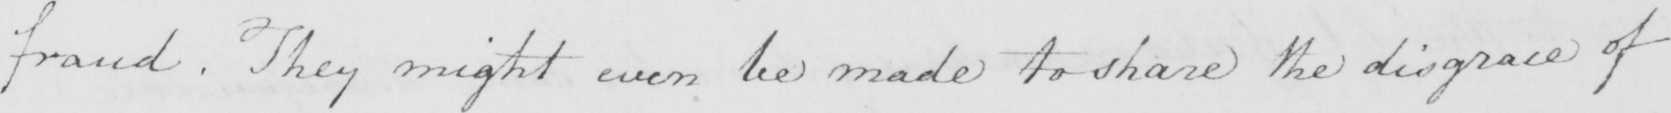What text is written in this handwritten line? fraud . They might even be made to share the disgrace of 